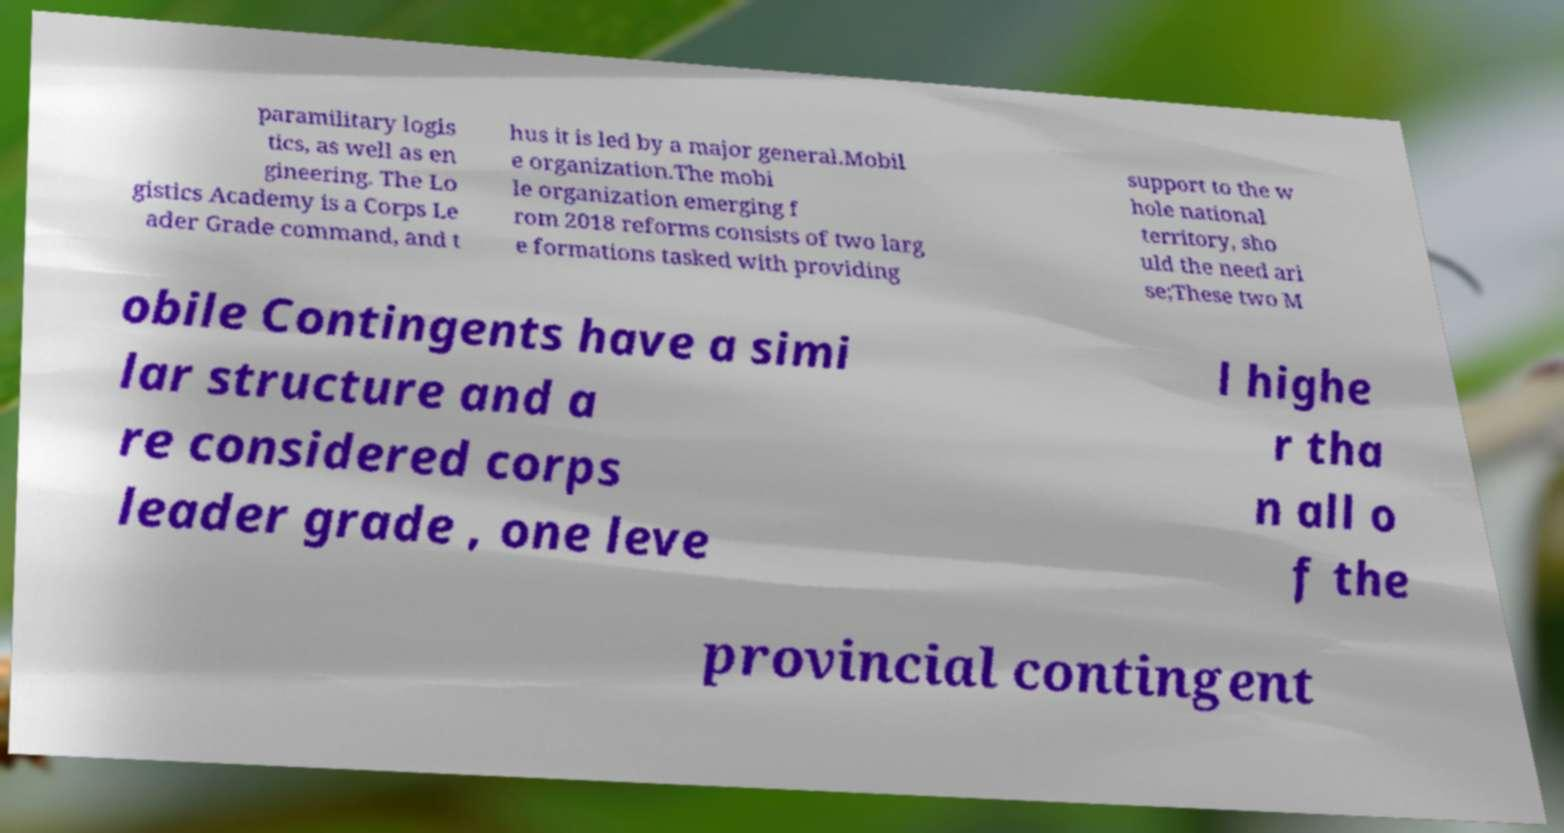Could you assist in decoding the text presented in this image and type it out clearly? paramilitary logis tics, as well as en gineering. The Lo gistics Academy is a Corps Le ader Grade command, and t hus it is led by a major general.Mobil e organization.The mobi le organization emerging f rom 2018 reforms consists of two larg e formations tasked with providing support to the w hole national territory, sho uld the need ari se;These two M obile Contingents have a simi lar structure and a re considered corps leader grade , one leve l highe r tha n all o f the provincial contingent 